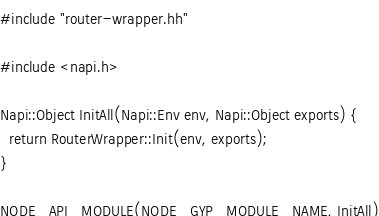<code> <loc_0><loc_0><loc_500><loc_500><_C++_>#include "router-wrapper.hh"

#include <napi.h>

Napi::Object InitAll(Napi::Env env, Napi::Object exports) {
  return RouterWrapper::Init(env, exports);
}

NODE_API_MODULE(NODE_GYP_MODULE_NAME, InitAll)
</code> 